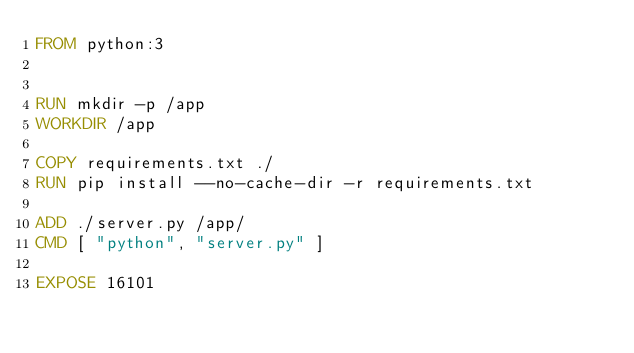Convert code to text. <code><loc_0><loc_0><loc_500><loc_500><_Dockerfile_>FROM python:3


RUN mkdir -p /app
WORKDIR /app

COPY requirements.txt ./
RUN pip install --no-cache-dir -r requirements.txt

ADD ./server.py /app/
CMD [ "python", "server.py" ]

EXPOSE 16101</code> 